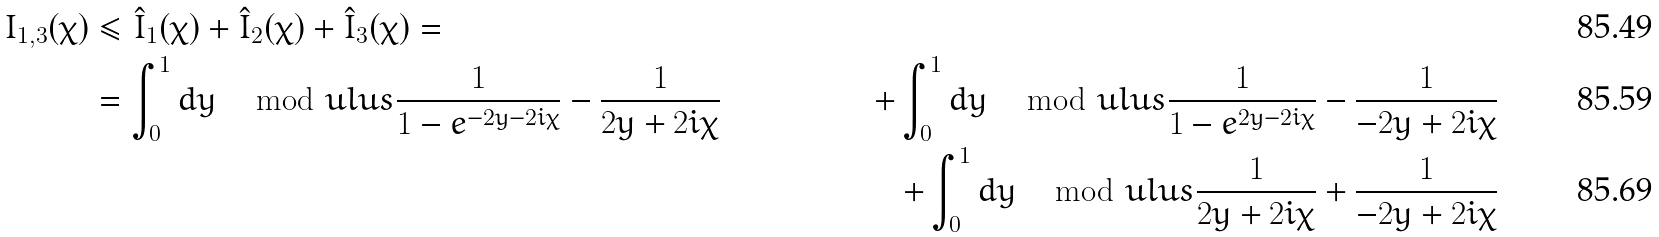Convert formula to latex. <formula><loc_0><loc_0><loc_500><loc_500>I _ { 1 , 3 } ( \chi ) & \leq \hat { I } _ { 1 } ( \chi ) + \hat { I } _ { 2 } ( \chi ) + \hat { I } _ { 3 } ( \chi ) = & \\ & = \int ^ { 1 } _ { 0 } d y \, \mod u l u s { \frac { 1 } { 1 - e ^ { - 2 y - 2 i \chi } } - \frac { 1 } { 2 y + 2 i \chi } } & + \int ^ { 1 } _ { 0 } d y \, \mod u l u s { \frac { 1 } { 1 - e ^ { 2 y - 2 i \chi } } - \frac { 1 } { - 2 y + 2 i \chi } } \\ & & + \int ^ { 1 } _ { 0 } d y \, \mod u l u s { \frac { 1 } { 2 y + 2 i \chi } + \frac { 1 } { - 2 y + 2 i \chi } }</formula> 